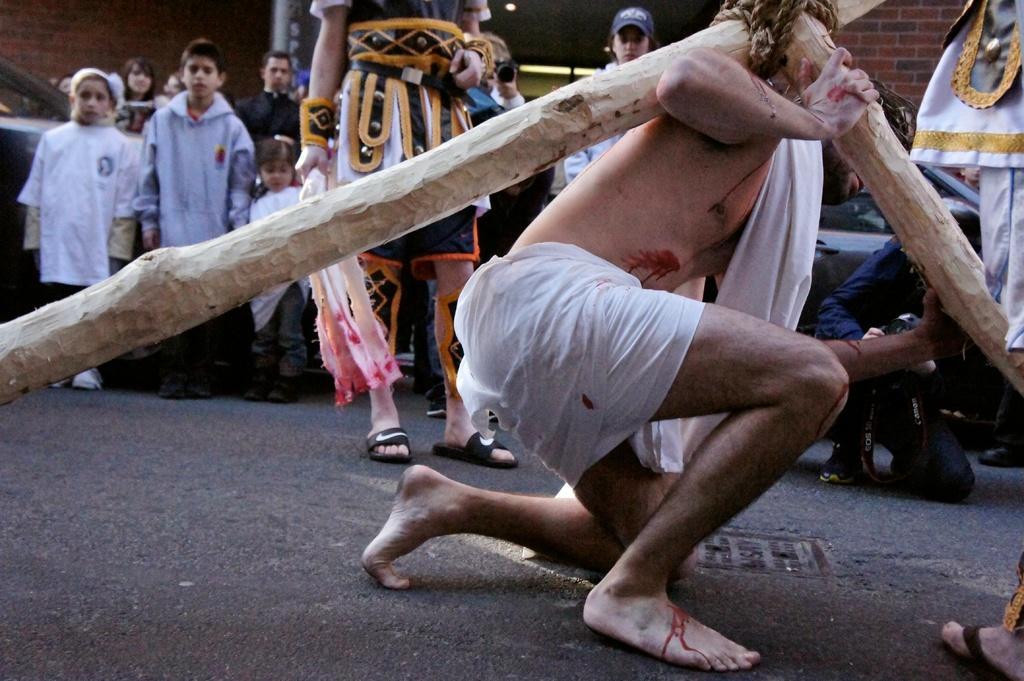Please provide a concise description of this image. In this image we can see a person sitting on his knees and he is holding wooden sticks on his shoulder, behind him there are a few people standing and one person holding camera. 